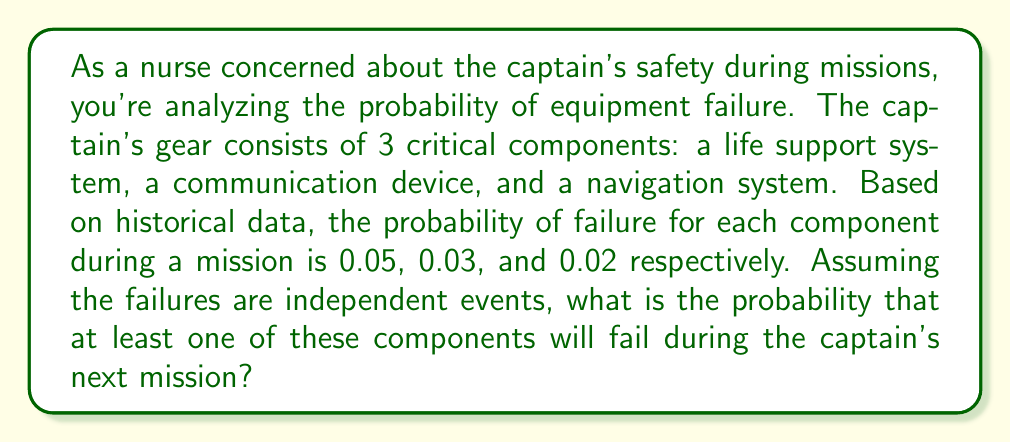Show me your answer to this math problem. To solve this problem, we'll use the complement rule of probability and the multiplication rule for independent events.

1) First, let's define our events:
   A: Life support system fails (P(A) = 0.05)
   B: Communication device fails (P(B) = 0.03)
   C: Navigation system fails (P(C) = 0.02)

2) We want to find P(at least one fails) = 1 - P(none fail)

3) P(none fail) = P(A' and B' and C'), where ' denotes the complement event

4) Since the events are independent:
   P(A' and B' and C') = P(A') × P(B') × P(C')

5) We can calculate each probability:
   P(A') = 1 - P(A) = 1 - 0.05 = 0.95
   P(B') = 1 - P(B) = 1 - 0.03 = 0.97
   P(C') = 1 - P(C) = 1 - 0.02 = 0.98

6) Now we can multiply:
   P(none fail) = 0.95 × 0.97 × 0.98 = 0.9023

7) Finally, we can find the probability of at least one failing:
   P(at least one fails) = 1 - P(none fail)
                         = 1 - 0.9023
                         = 0.0977

Therefore, the probability that at least one component will fail during the mission is approximately 0.0977 or 9.77%.
Answer: The probability that at least one of the critical components will fail during the captain's next mission is approximately $0.0977$ or $9.77\%$. 